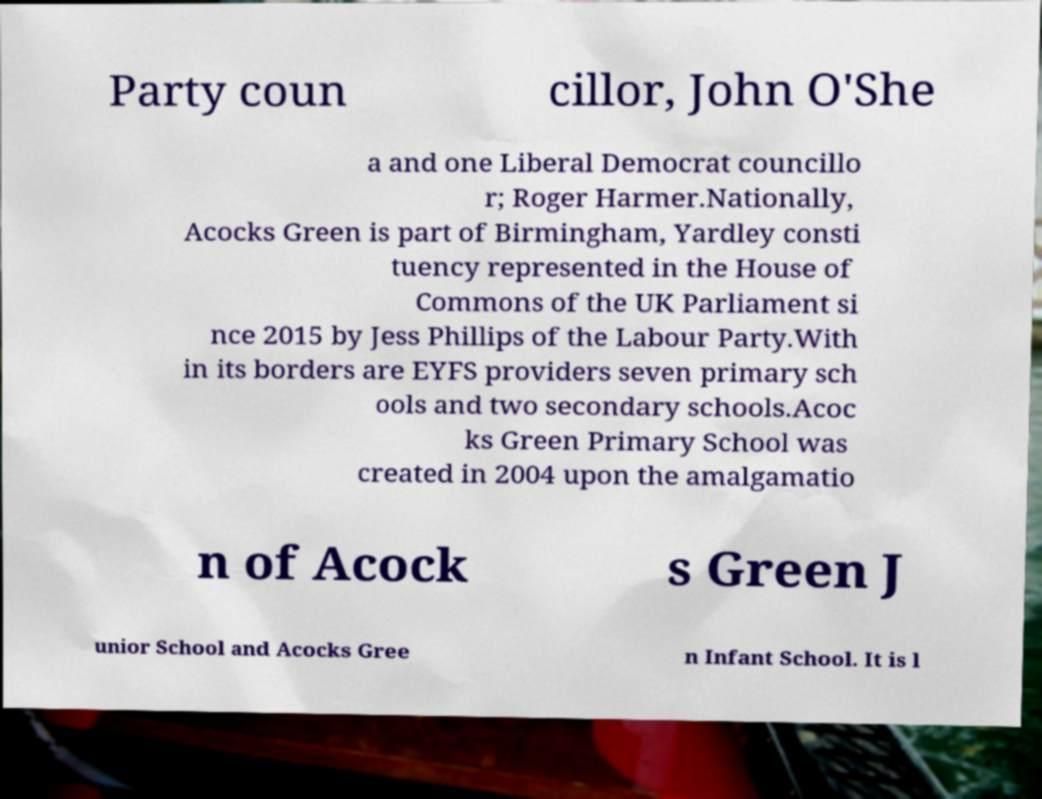Could you extract and type out the text from this image? Party coun cillor, John O'She a and one Liberal Democrat councillo r; Roger Harmer.Nationally, Acocks Green is part of Birmingham, Yardley consti tuency represented in the House of Commons of the UK Parliament si nce 2015 by Jess Phillips of the Labour Party.With in its borders are EYFS providers seven primary sch ools and two secondary schools.Acoc ks Green Primary School was created in 2004 upon the amalgamatio n of Acock s Green J unior School and Acocks Gree n Infant School. It is l 